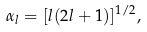<formula> <loc_0><loc_0><loc_500><loc_500>\alpha _ { l } = [ l ( 2 l + 1 ) ] ^ { 1 / 2 } ,</formula> 